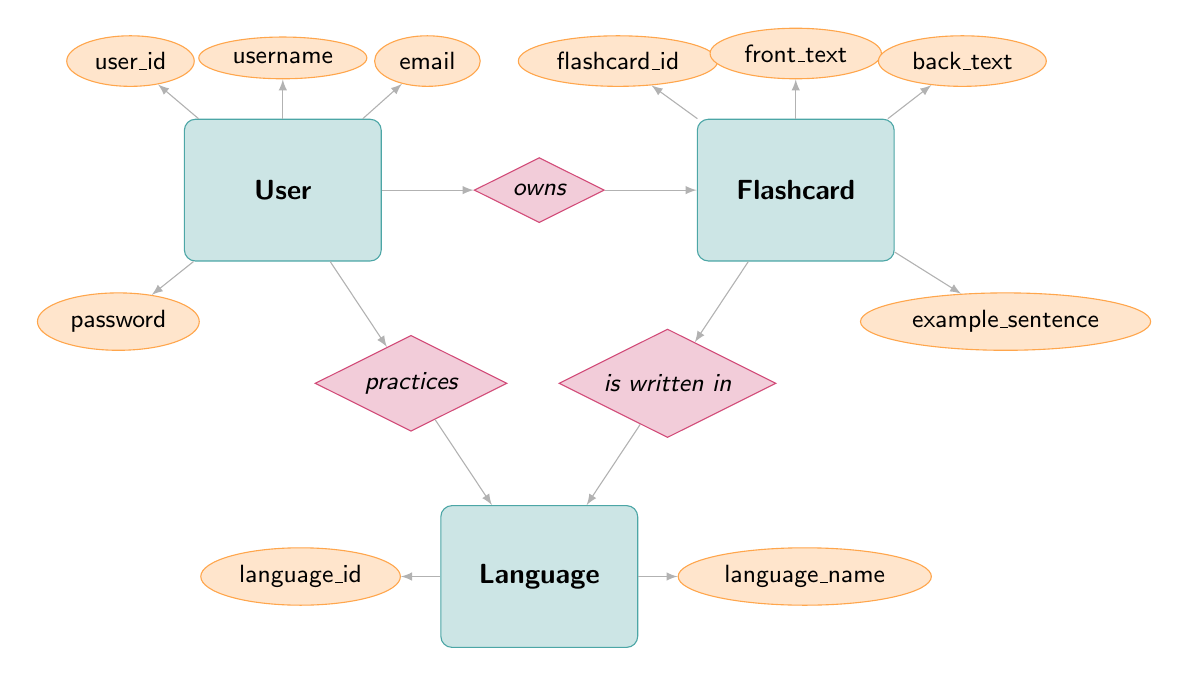What is the primary attribute of the User entity? The primary attribute of the User entity indicated in the diagram is "user_id". This attribute is positioned in the ellipse shape connected to the User entity node, which signifies it as a key piece of information about the User.
Answer: user_id How many relationships does the Flashcard entity have? The Flashcard entity has two relationships, one with the User (belongs to) and one with the Language (is written in). These relationships are shown as diamond shapes connecting the Flashcard entity to both the User and Language entities.
Answer: 2 Which entity is practiced by the User? According to the diagram, the User practices the Language. This is indicated by the diamond shape labeled "practices" between the User and Language entities.
Answer: Language What are the attributes associated with the Flashcard entity? The attributes associated with the Flashcard entity include "flashcard_id", "front_text", "back_text", and "example_sentence". These attributes are represented by ellipses connected to the Flashcard entity node.
Answer: flashcard_id, front_text, back_text, example_sentence What relationship type connects Language to Flashcard? The relationship type that connects Language to Flashcard is "has flashcards". This relationship is reflected in the diagram with a diamond shape labeled "has flashcards" positioned between the Language and Flashcard entities.
Answer: has flashcards Why does the Flashcard entity belong to the User? The Flashcard entity belongs to the User because of the "belongs to" relationship defined in the diagram. This relationship indicates that each Flashcard is associated with a User who owns it.
Answer: belongs to What is the total number of entities in the diagram? The total number of entities in the diagram is three: User, Flashcard, and Language. Each of these is represented as a rectangle labeled with the entity name, confirming their presence as distinct components in the system.
Answer: 3 Which attribute is associated with the Language entity? The attributes associated with the Language entity are "language_id" and "language_name". Both attributes are shown as ellipses connected to the Language entity, denoting essential information about the Language.
Answer: language_id, language_name 